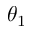<formula> <loc_0><loc_0><loc_500><loc_500>\theta _ { 1 }</formula> 